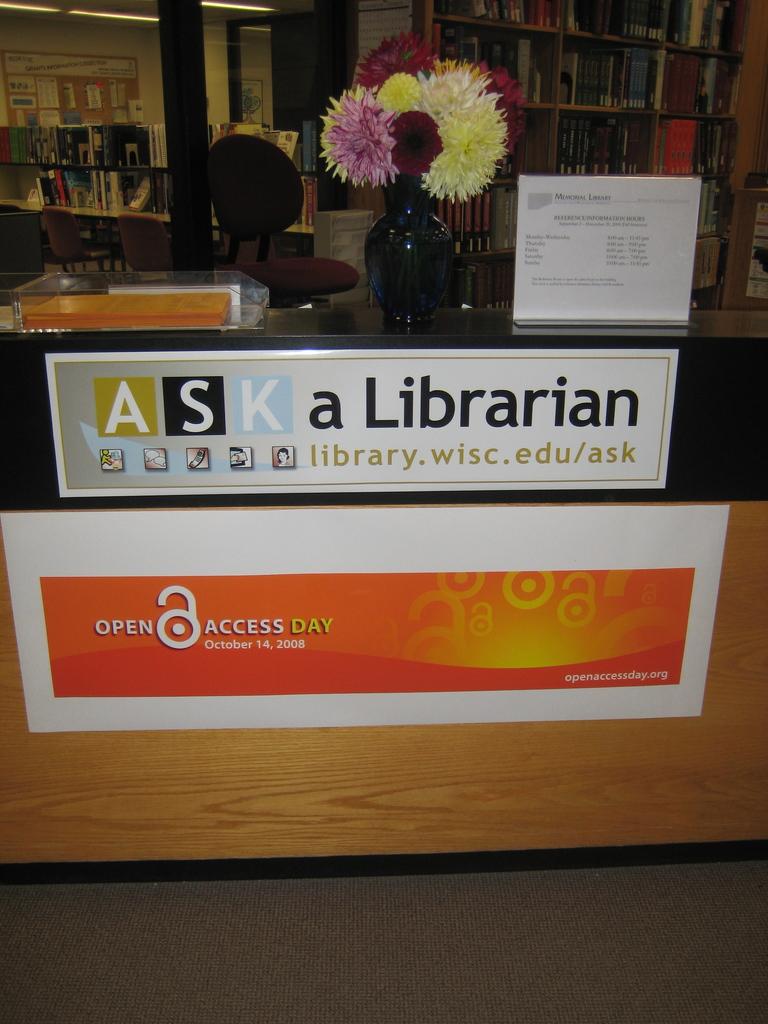When is open access day?
Give a very brief answer. October 14, 2008. 